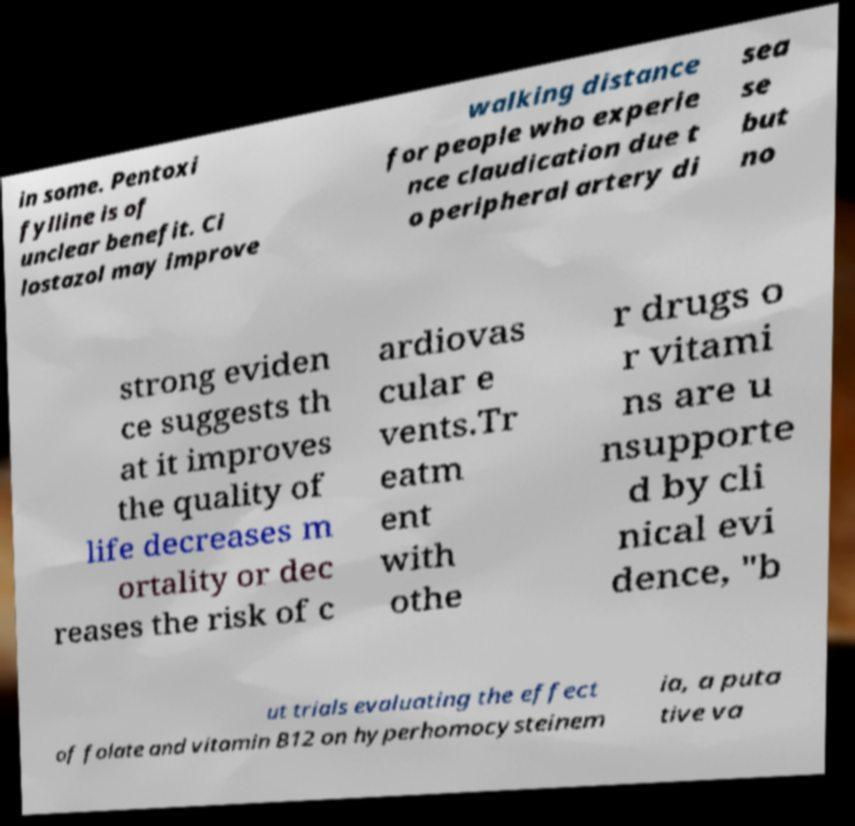Please identify and transcribe the text found in this image. in some. Pentoxi fylline is of unclear benefit. Ci lostazol may improve walking distance for people who experie nce claudication due t o peripheral artery di sea se but no strong eviden ce suggests th at it improves the quality of life decreases m ortality or dec reases the risk of c ardiovas cular e vents.Tr eatm ent with othe r drugs o r vitami ns are u nsupporte d by cli nical evi dence, "b ut trials evaluating the effect of folate and vitamin B12 on hyperhomocysteinem ia, a puta tive va 